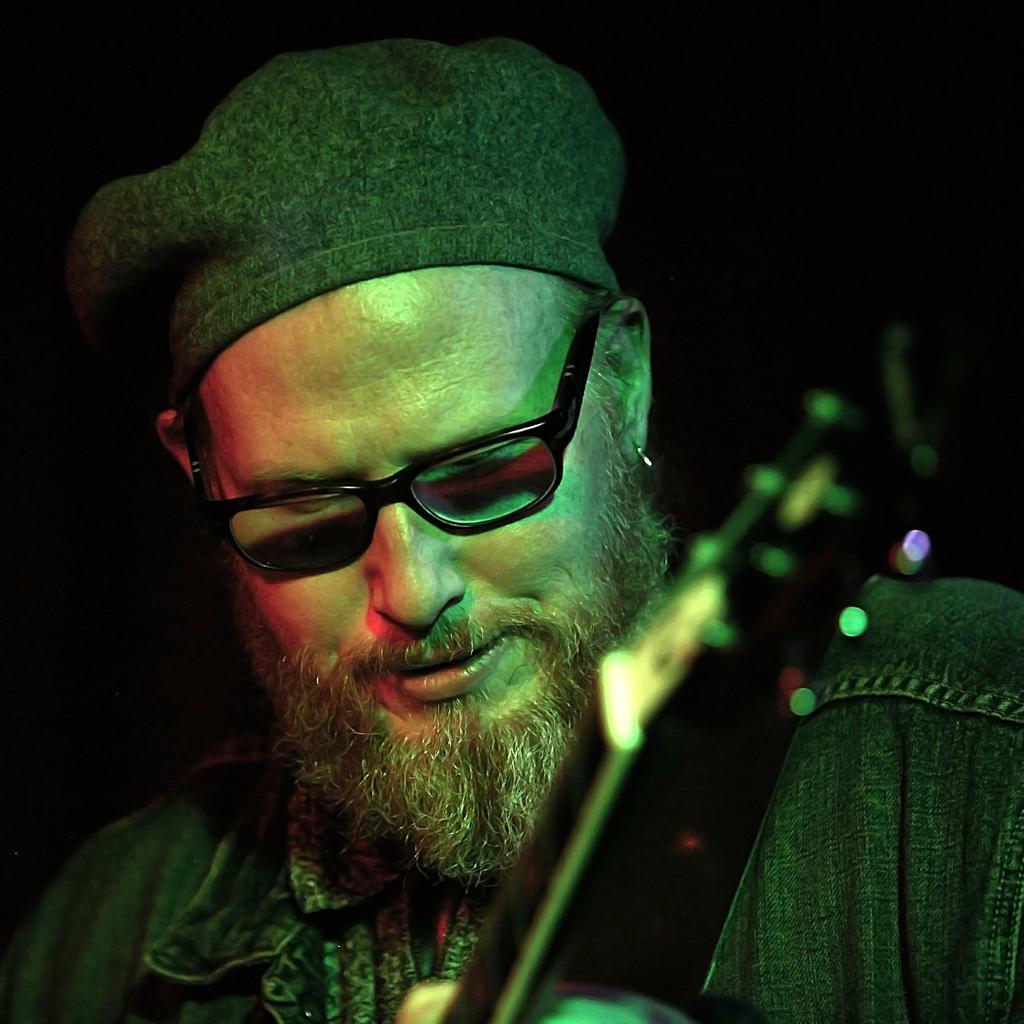Describe this image in one or two sentences. In the image there is a man with spectacles and a hat on his head. And also here is a musical instrument. Behind him there is a black background. 